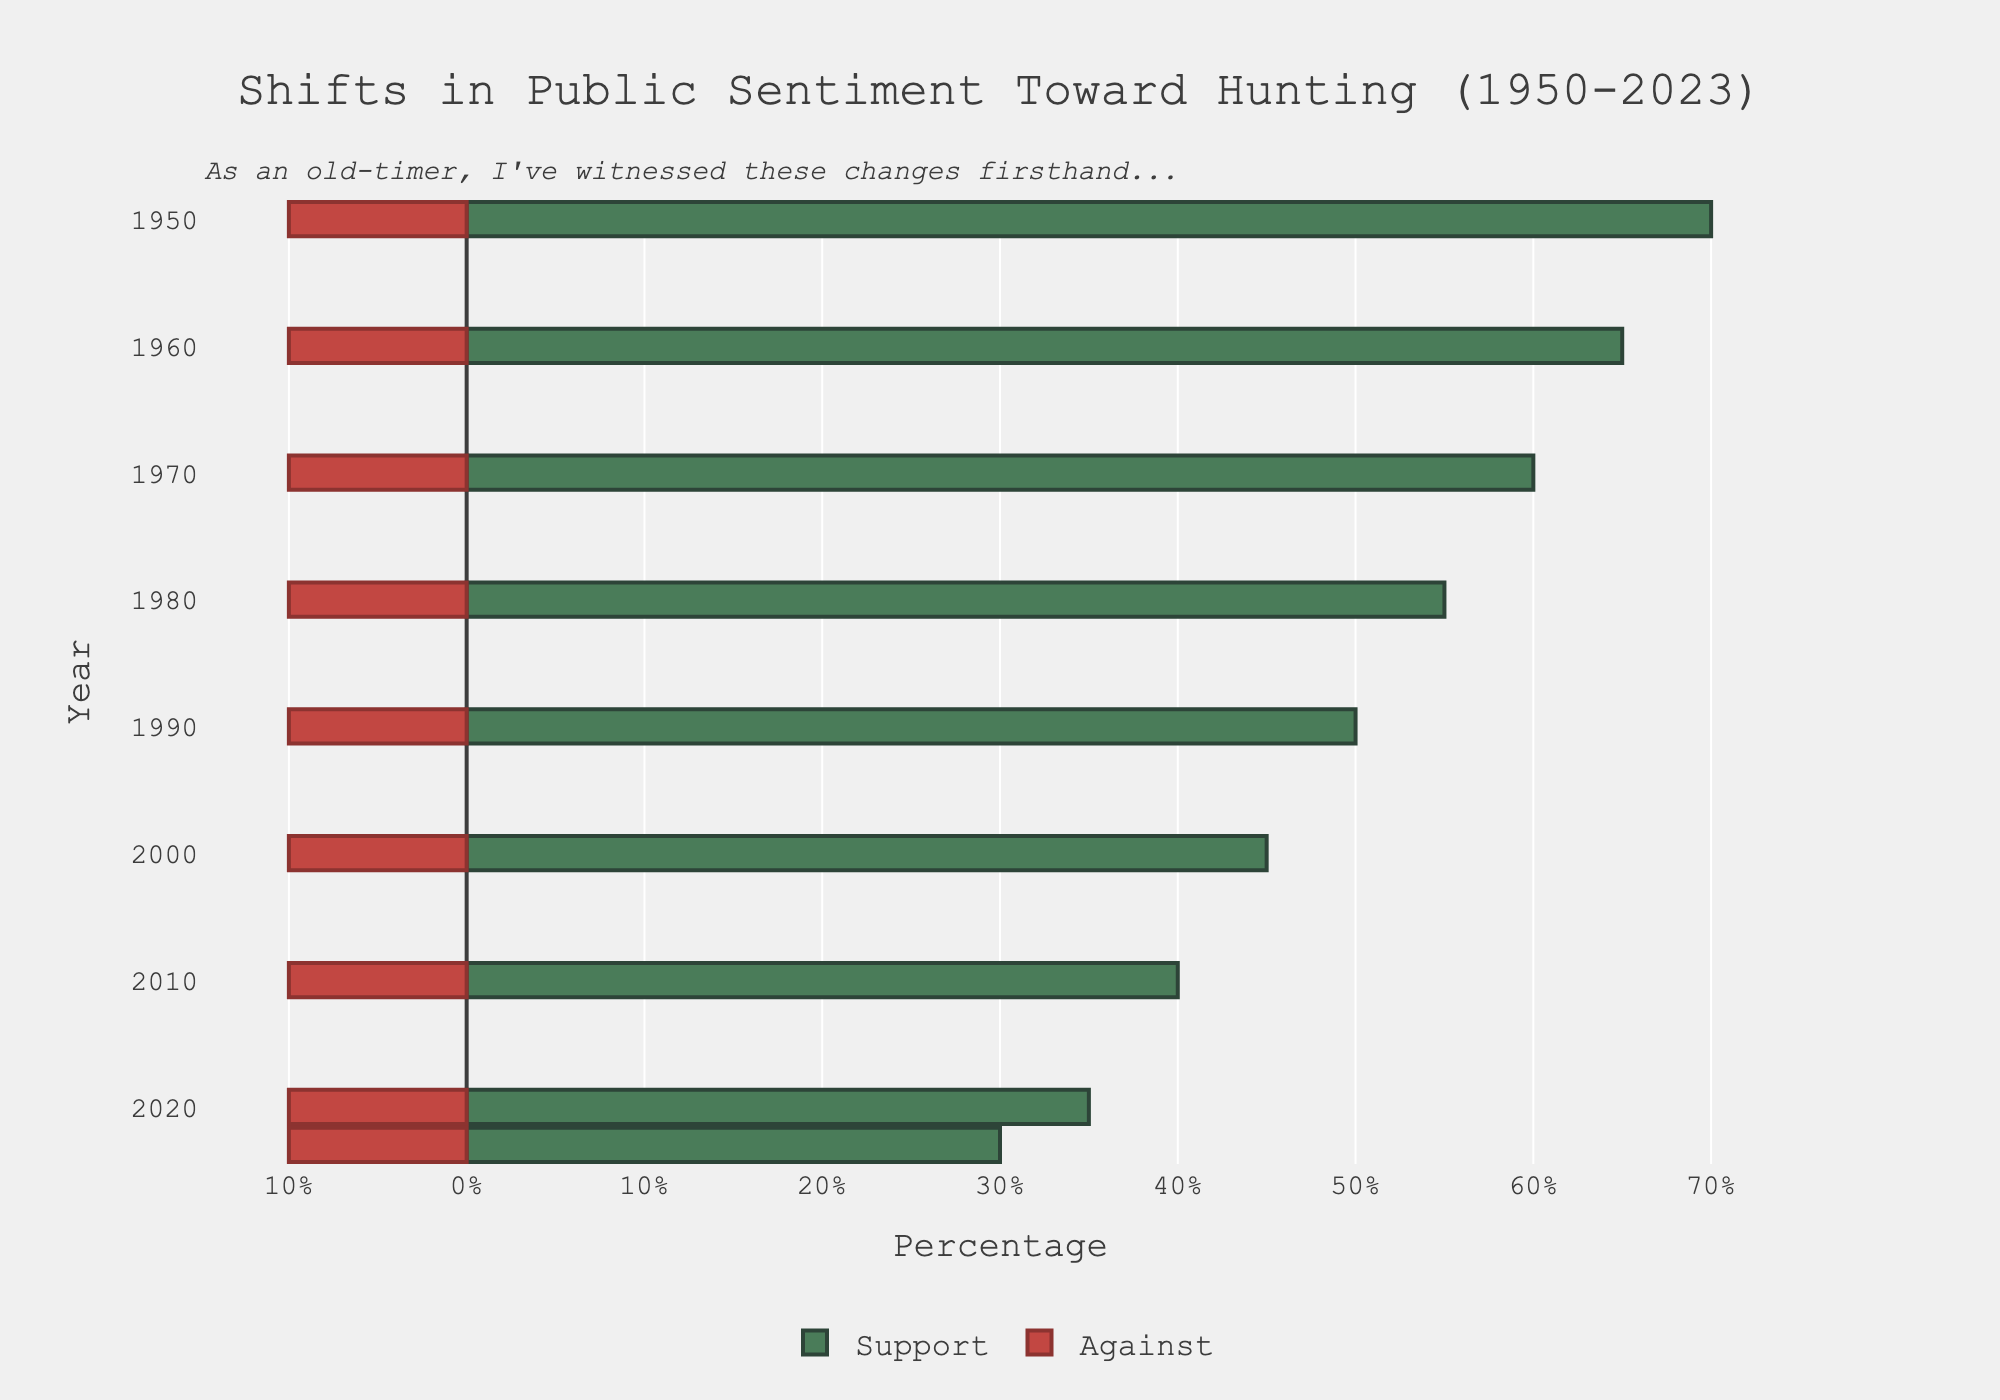Which year had the highest percentage of people supporting hunting? The bar for the year 1950 extends the furthest to the right under the "Support" category.
Answer: 1950 By how much did the support for hunting decrease from 1950 to 2023? The support in 1950 was 70%, and in 2023 it is 30%. The decrease is 70% - 30% = 40%.
Answer: 40% How did the sentiment against hunting change from 1950 to 2023? The bar for the "Against" category remains constant through all years, consistently representing 10%, indicating no change.
Answer: No change What is the midpoint year when the support for hunting and the sentiment against it were approximately equal? By observing the intersection of the "Support" and "Against" bars, they are closest in the year 2000 when both sentiments were 45%.
Answer: 2000 From 1980 to 2023, how much has the support for hunting changed? Support in 1980 was 55%, and in 2023 it is 30%. The change is 55% - 30% = 25%.
Answer: 25% What is the overall trend in public sentiment towards hunting over the years? The "Support" bars gradually decrease from left to right (70% in 1950 to 30% in 2023), and the "Hannah" bars increase over time (20% in 1950 to 60% in 2023). The "Against" bar remains constant at 10%.
Answer: Support decreases, Hannah increases, Against constant Compare the support and against sentiments for hunting in the year 1990. Support for 1990 is shown by a bar extending to 50% on the right, while Against for 1990 extends 10% to the left. Hence, support is much higher.
Answer: Support higher In which year did the sentiment named "Hannah" exceed the support sentiment for the first time? By observing the bar lengths, "Hannah" overtakes the support in 2000 when "Hannah" sentiment is at 45%, and support drops to 45%.
Answer: 2000 